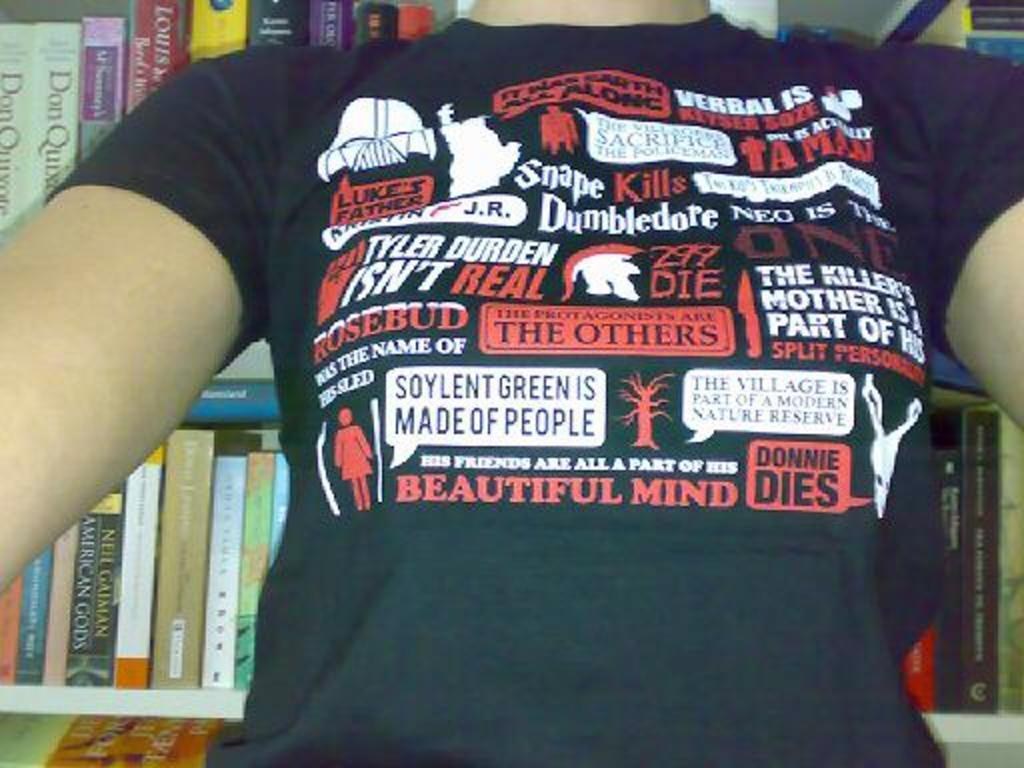<image>
Give a short and clear explanation of the subsequent image. Shirt with Beautiful Mind, Donnie Dies, Rosebud, and Tyler Durden Isn't real. 